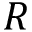Convert formula to latex. <formula><loc_0><loc_0><loc_500><loc_500>R</formula> 